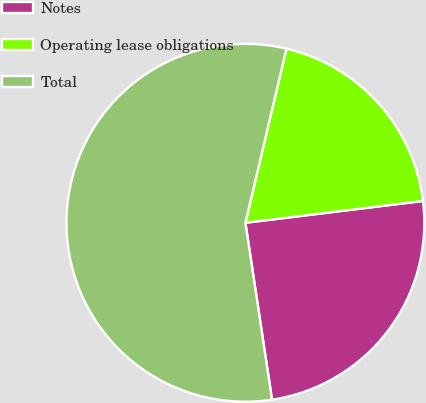Convert chart to OTSL. <chart><loc_0><loc_0><loc_500><loc_500><pie_chart><fcel>Notes<fcel>Operating lease obligations<fcel>Total<nl><fcel>24.57%<fcel>19.37%<fcel>56.06%<nl></chart> 